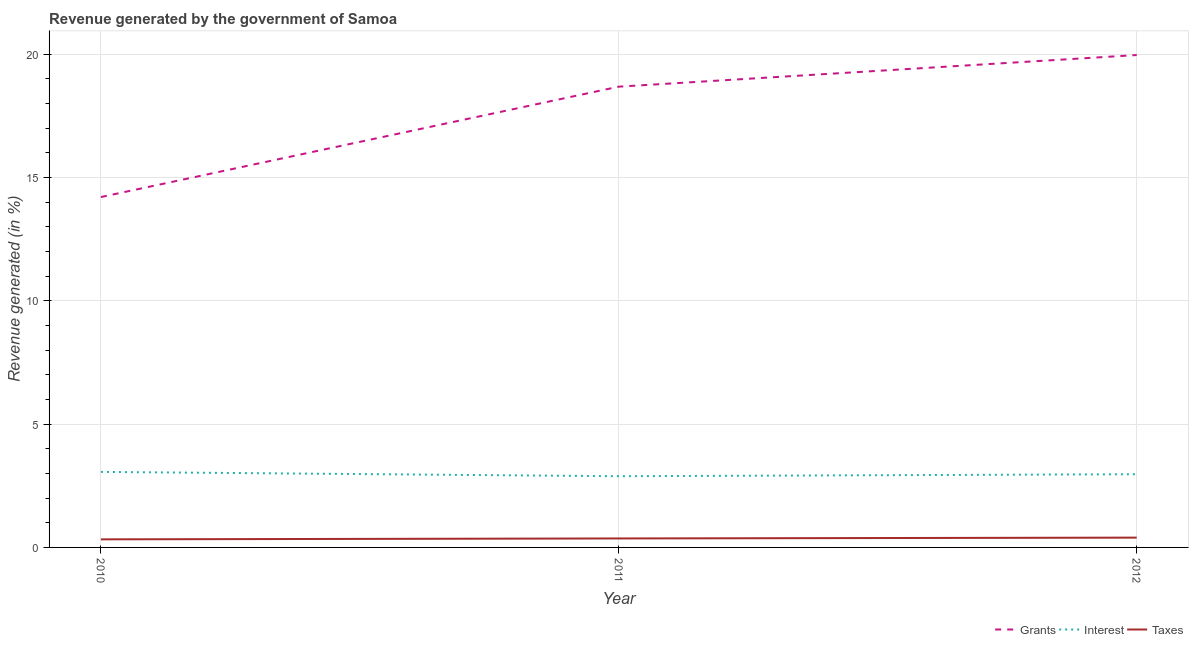How many different coloured lines are there?
Give a very brief answer. 3. What is the percentage of revenue generated by grants in 2011?
Give a very brief answer. 18.68. Across all years, what is the maximum percentage of revenue generated by taxes?
Offer a very short reply. 0.4. Across all years, what is the minimum percentage of revenue generated by grants?
Your answer should be compact. 14.2. What is the total percentage of revenue generated by interest in the graph?
Offer a very short reply. 8.92. What is the difference between the percentage of revenue generated by taxes in 2010 and that in 2012?
Offer a terse response. -0.07. What is the difference between the percentage of revenue generated by grants in 2010 and the percentage of revenue generated by interest in 2011?
Keep it short and to the point. 11.32. What is the average percentage of revenue generated by taxes per year?
Offer a terse response. 0.36. In the year 2010, what is the difference between the percentage of revenue generated by grants and percentage of revenue generated by taxes?
Make the answer very short. 13.88. In how many years, is the percentage of revenue generated by grants greater than 9 %?
Your answer should be very brief. 3. What is the ratio of the percentage of revenue generated by grants in 2010 to that in 2011?
Ensure brevity in your answer.  0.76. Is the percentage of revenue generated by grants in 2010 less than that in 2012?
Provide a succinct answer. Yes. What is the difference between the highest and the second highest percentage of revenue generated by interest?
Give a very brief answer. 0.09. What is the difference between the highest and the lowest percentage of revenue generated by taxes?
Offer a terse response. 0.07. In how many years, is the percentage of revenue generated by taxes greater than the average percentage of revenue generated by taxes taken over all years?
Your answer should be very brief. 2. Is it the case that in every year, the sum of the percentage of revenue generated by grants and percentage of revenue generated by interest is greater than the percentage of revenue generated by taxes?
Provide a succinct answer. Yes. Is the percentage of revenue generated by grants strictly less than the percentage of revenue generated by interest over the years?
Your response must be concise. No. How many lines are there?
Your answer should be compact. 3. What is the difference between two consecutive major ticks on the Y-axis?
Your answer should be very brief. 5. Where does the legend appear in the graph?
Your answer should be very brief. Bottom right. How many legend labels are there?
Provide a short and direct response. 3. What is the title of the graph?
Provide a succinct answer. Revenue generated by the government of Samoa. What is the label or title of the X-axis?
Provide a succinct answer. Year. What is the label or title of the Y-axis?
Ensure brevity in your answer.  Revenue generated (in %). What is the Revenue generated (in %) of Grants in 2010?
Offer a very short reply. 14.2. What is the Revenue generated (in %) of Interest in 2010?
Your answer should be very brief. 3.06. What is the Revenue generated (in %) in Taxes in 2010?
Make the answer very short. 0.33. What is the Revenue generated (in %) of Grants in 2011?
Offer a terse response. 18.68. What is the Revenue generated (in %) of Interest in 2011?
Give a very brief answer. 2.89. What is the Revenue generated (in %) of Taxes in 2011?
Offer a very short reply. 0.36. What is the Revenue generated (in %) of Grants in 2012?
Your response must be concise. 19.96. What is the Revenue generated (in %) of Interest in 2012?
Offer a very short reply. 2.97. What is the Revenue generated (in %) in Taxes in 2012?
Your answer should be very brief. 0.4. Across all years, what is the maximum Revenue generated (in %) of Grants?
Offer a terse response. 19.96. Across all years, what is the maximum Revenue generated (in %) of Interest?
Your answer should be compact. 3.06. Across all years, what is the maximum Revenue generated (in %) of Taxes?
Give a very brief answer. 0.4. Across all years, what is the minimum Revenue generated (in %) of Grants?
Ensure brevity in your answer.  14.2. Across all years, what is the minimum Revenue generated (in %) in Interest?
Offer a terse response. 2.89. Across all years, what is the minimum Revenue generated (in %) in Taxes?
Your response must be concise. 0.33. What is the total Revenue generated (in %) of Grants in the graph?
Offer a terse response. 52.84. What is the total Revenue generated (in %) of Interest in the graph?
Give a very brief answer. 8.92. What is the total Revenue generated (in %) in Taxes in the graph?
Keep it short and to the point. 1.09. What is the difference between the Revenue generated (in %) of Grants in 2010 and that in 2011?
Offer a terse response. -4.47. What is the difference between the Revenue generated (in %) in Interest in 2010 and that in 2011?
Keep it short and to the point. 0.18. What is the difference between the Revenue generated (in %) of Taxes in 2010 and that in 2011?
Provide a succinct answer. -0.04. What is the difference between the Revenue generated (in %) in Grants in 2010 and that in 2012?
Give a very brief answer. -5.76. What is the difference between the Revenue generated (in %) in Interest in 2010 and that in 2012?
Your answer should be compact. 0.09. What is the difference between the Revenue generated (in %) of Taxes in 2010 and that in 2012?
Your answer should be very brief. -0.07. What is the difference between the Revenue generated (in %) of Grants in 2011 and that in 2012?
Make the answer very short. -1.28. What is the difference between the Revenue generated (in %) of Interest in 2011 and that in 2012?
Offer a very short reply. -0.08. What is the difference between the Revenue generated (in %) of Taxes in 2011 and that in 2012?
Your answer should be very brief. -0.03. What is the difference between the Revenue generated (in %) in Grants in 2010 and the Revenue generated (in %) in Interest in 2011?
Ensure brevity in your answer.  11.32. What is the difference between the Revenue generated (in %) in Grants in 2010 and the Revenue generated (in %) in Taxes in 2011?
Make the answer very short. 13.84. What is the difference between the Revenue generated (in %) in Interest in 2010 and the Revenue generated (in %) in Taxes in 2011?
Keep it short and to the point. 2.7. What is the difference between the Revenue generated (in %) of Grants in 2010 and the Revenue generated (in %) of Interest in 2012?
Your answer should be compact. 11.24. What is the difference between the Revenue generated (in %) in Grants in 2010 and the Revenue generated (in %) in Taxes in 2012?
Offer a very short reply. 13.81. What is the difference between the Revenue generated (in %) of Interest in 2010 and the Revenue generated (in %) of Taxes in 2012?
Provide a succinct answer. 2.66. What is the difference between the Revenue generated (in %) of Grants in 2011 and the Revenue generated (in %) of Interest in 2012?
Offer a very short reply. 15.71. What is the difference between the Revenue generated (in %) in Grants in 2011 and the Revenue generated (in %) in Taxes in 2012?
Your answer should be compact. 18.28. What is the difference between the Revenue generated (in %) of Interest in 2011 and the Revenue generated (in %) of Taxes in 2012?
Offer a terse response. 2.49. What is the average Revenue generated (in %) of Grants per year?
Your response must be concise. 17.61. What is the average Revenue generated (in %) in Interest per year?
Offer a terse response. 2.97. What is the average Revenue generated (in %) of Taxes per year?
Provide a short and direct response. 0.36. In the year 2010, what is the difference between the Revenue generated (in %) of Grants and Revenue generated (in %) of Interest?
Provide a succinct answer. 11.14. In the year 2010, what is the difference between the Revenue generated (in %) in Grants and Revenue generated (in %) in Taxes?
Offer a very short reply. 13.88. In the year 2010, what is the difference between the Revenue generated (in %) of Interest and Revenue generated (in %) of Taxes?
Offer a terse response. 2.73. In the year 2011, what is the difference between the Revenue generated (in %) in Grants and Revenue generated (in %) in Interest?
Make the answer very short. 15.79. In the year 2011, what is the difference between the Revenue generated (in %) in Grants and Revenue generated (in %) in Taxes?
Ensure brevity in your answer.  18.31. In the year 2011, what is the difference between the Revenue generated (in %) in Interest and Revenue generated (in %) in Taxes?
Your response must be concise. 2.52. In the year 2012, what is the difference between the Revenue generated (in %) in Grants and Revenue generated (in %) in Interest?
Make the answer very short. 16.99. In the year 2012, what is the difference between the Revenue generated (in %) of Grants and Revenue generated (in %) of Taxes?
Offer a very short reply. 19.56. In the year 2012, what is the difference between the Revenue generated (in %) in Interest and Revenue generated (in %) in Taxes?
Ensure brevity in your answer.  2.57. What is the ratio of the Revenue generated (in %) in Grants in 2010 to that in 2011?
Provide a succinct answer. 0.76. What is the ratio of the Revenue generated (in %) of Interest in 2010 to that in 2011?
Offer a very short reply. 1.06. What is the ratio of the Revenue generated (in %) in Taxes in 2010 to that in 2011?
Ensure brevity in your answer.  0.9. What is the ratio of the Revenue generated (in %) in Grants in 2010 to that in 2012?
Give a very brief answer. 0.71. What is the ratio of the Revenue generated (in %) of Interest in 2010 to that in 2012?
Provide a short and direct response. 1.03. What is the ratio of the Revenue generated (in %) of Taxes in 2010 to that in 2012?
Provide a succinct answer. 0.82. What is the ratio of the Revenue generated (in %) of Grants in 2011 to that in 2012?
Your response must be concise. 0.94. What is the ratio of the Revenue generated (in %) of Interest in 2011 to that in 2012?
Your answer should be compact. 0.97. What is the ratio of the Revenue generated (in %) in Taxes in 2011 to that in 2012?
Provide a succinct answer. 0.92. What is the difference between the highest and the second highest Revenue generated (in %) of Grants?
Your answer should be compact. 1.28. What is the difference between the highest and the second highest Revenue generated (in %) of Interest?
Provide a short and direct response. 0.09. What is the difference between the highest and the second highest Revenue generated (in %) in Taxes?
Ensure brevity in your answer.  0.03. What is the difference between the highest and the lowest Revenue generated (in %) in Grants?
Make the answer very short. 5.76. What is the difference between the highest and the lowest Revenue generated (in %) of Interest?
Offer a very short reply. 0.18. What is the difference between the highest and the lowest Revenue generated (in %) of Taxes?
Provide a succinct answer. 0.07. 